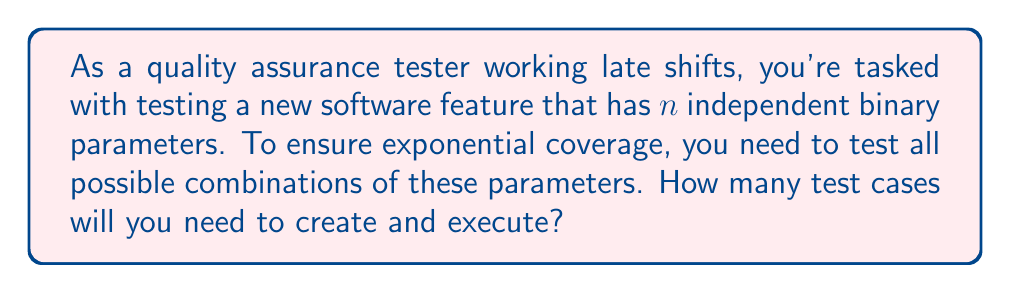Can you solve this math problem? To solve this problem, we need to understand the concept of exponential coverage in software testing:

1. Exponential coverage means testing all possible combinations of parameters.

2. Each parameter is binary, meaning it can have two possible values (e.g., on/off, true/false).

3. There are $n$ independent parameters.

The number of test cases for exponential coverage is calculated using the following steps:

1. For each parameter, we have 2 choices.

2. We need to consider all possible combinations of these choices for all $n$ parameters.

3. In combinatorics, when we have independent events and we want to find the total number of possible outcomes, we multiply the number of possibilities for each event.

4. Therefore, the total number of test cases is:

   $$ \text{Number of test cases} = 2 \times 2 \times 2 \times \ldots \text{ (n times)} $$

5. This can be written more concisely using exponents:

   $$ \text{Number of test cases} = 2^n $$

This formula, $2^n$, represents the exponential growth of test cases as the number of parameters increases, hence the term "exponential coverage."
Answer: $2^n$ test cases 